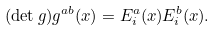<formula> <loc_0><loc_0><loc_500><loc_500>( \det g ) g ^ { a b } ( x ) = E ^ { a } _ { i } ( x ) E ^ { b } _ { i } ( x ) .</formula> 